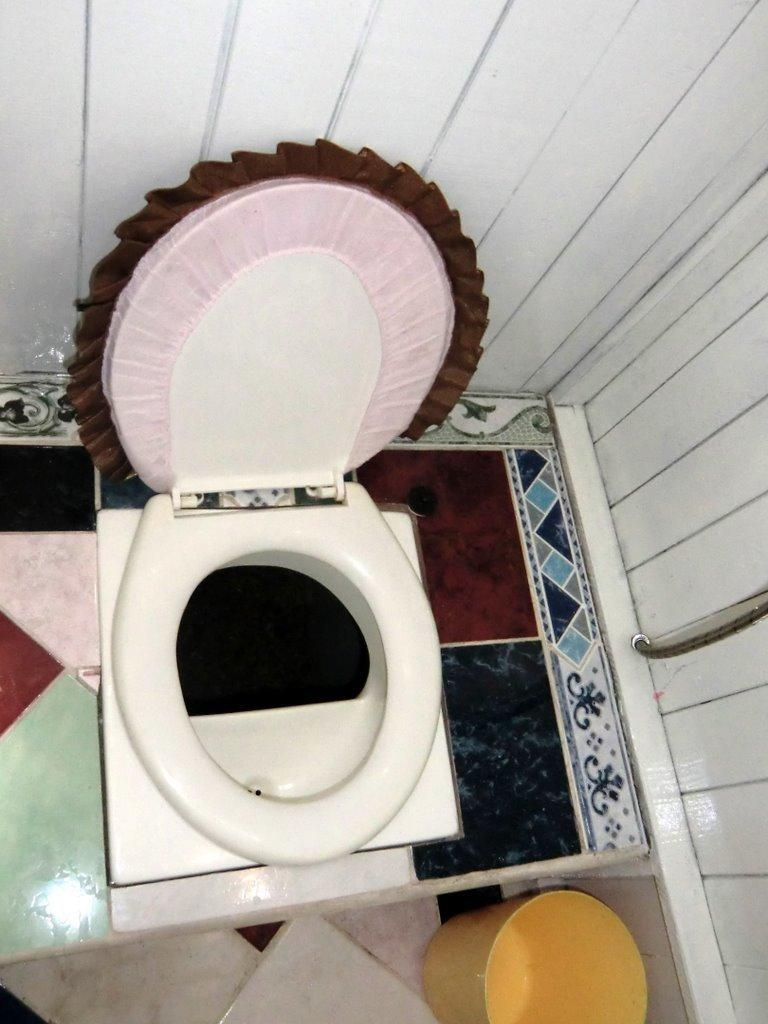What type of furniture is in the image? There is a commode in the image. What is located at the bottom of the commode? There is a bucket at the bottom of the commode. What type of flooring is visible in the image? Tiles are visible in the image. What is on the right side of the image? There is a pipe on the right side of the image. What is the background of the image made of? There is a wall in the image. What type of vein can be seen running through the tiles in the image? There are no veins visible in the image; the tiles are a solid material. 